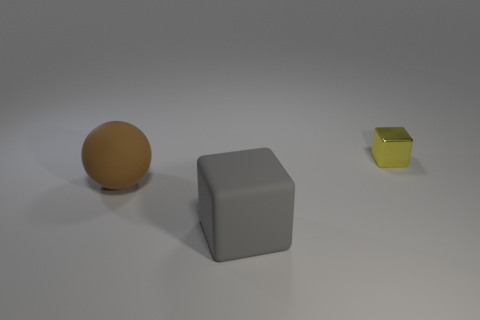Are there any other things that are the same size as the yellow object?
Your answer should be compact. No. How big is the object that is behind the matte block and to the right of the sphere?
Your answer should be very brief. Small. What is the color of the big rubber object that is on the right side of the large rubber thing to the left of the block that is to the left of the small shiny block?
Provide a short and direct response. Gray. How many objects are rubber objects or big brown spheres?
Provide a succinct answer. 2. How many big matte objects have the same shape as the tiny thing?
Offer a very short reply. 1. Is the large sphere made of the same material as the object in front of the brown rubber ball?
Ensure brevity in your answer.  Yes. There is a brown thing that is made of the same material as the gray cube; what is its size?
Keep it short and to the point. Large. What size is the cube that is in front of the large brown rubber sphere?
Offer a terse response. Large. How many brown matte spheres have the same size as the brown rubber thing?
Give a very brief answer. 0. What is the color of the other object that is the same size as the brown object?
Ensure brevity in your answer.  Gray. 